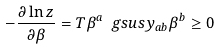Convert formula to latex. <formula><loc_0><loc_0><loc_500><loc_500>- \frac { \partial \ln z } { \partial \beta } = T \beta ^ { a } \ g s u s y _ { a b } \beta ^ { b } \geq 0</formula> 